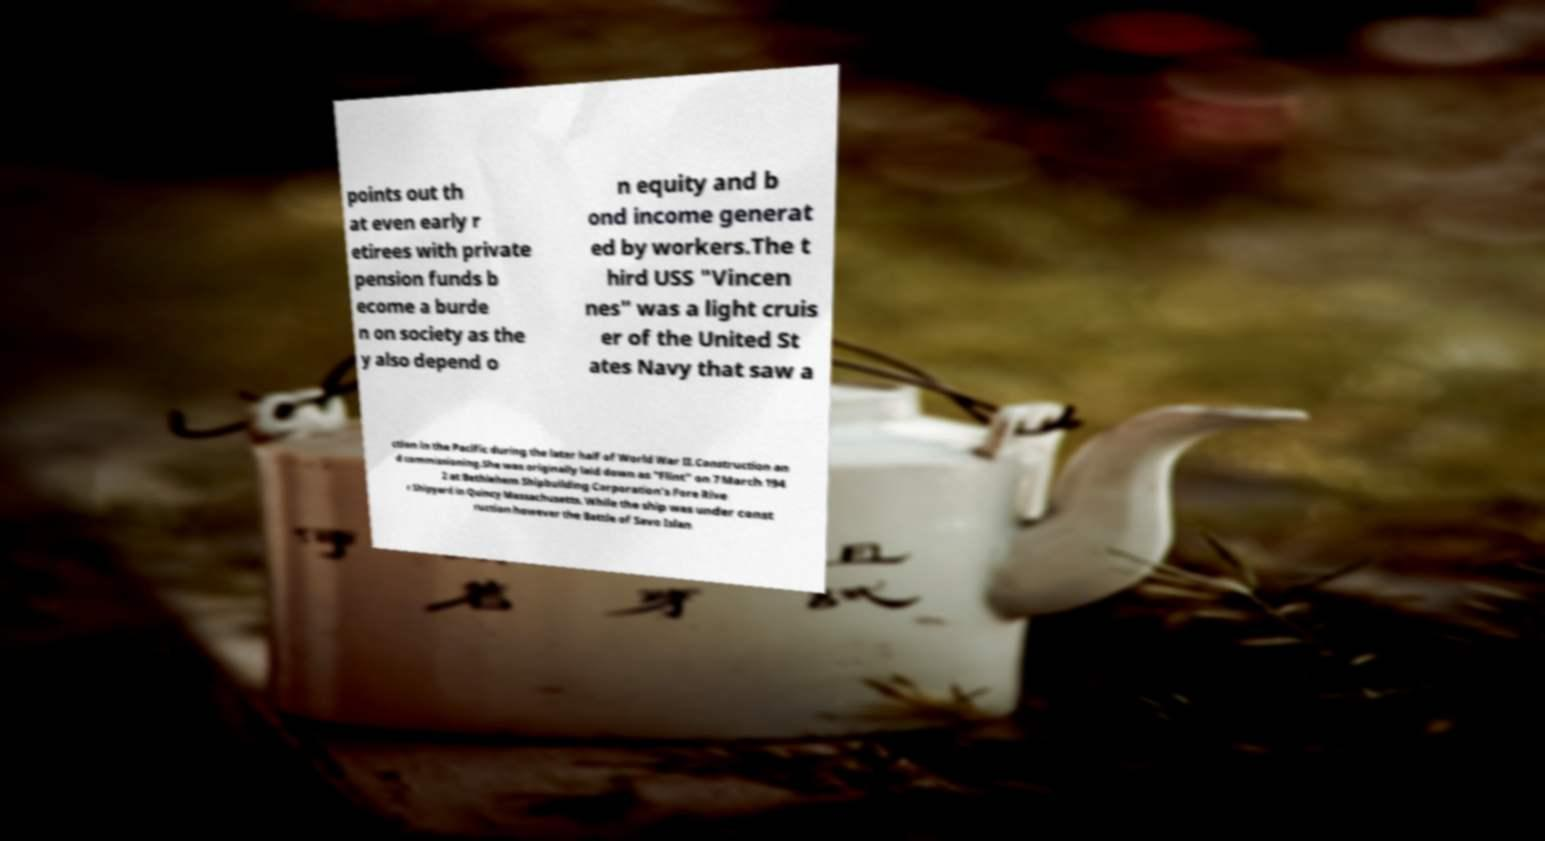I need the written content from this picture converted into text. Can you do that? points out th at even early r etirees with private pension funds b ecome a burde n on society as the y also depend o n equity and b ond income generat ed by workers.The t hird USS "Vincen nes" was a light cruis er of the United St ates Navy that saw a ction in the Pacific during the later half of World War II.Construction an d commissioning.She was originally laid down as "Flint" on 7 March 194 2 at Bethlehem Shipbuilding Corporation's Fore Rive r Shipyard in Quincy Massachusetts. While the ship was under const ruction however the Battle of Savo Islan 